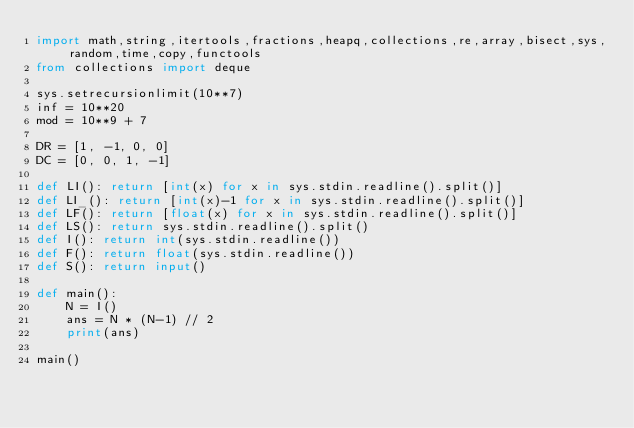<code> <loc_0><loc_0><loc_500><loc_500><_Python_>import math,string,itertools,fractions,heapq,collections,re,array,bisect,sys,random,time,copy,functools
from collections import deque

sys.setrecursionlimit(10**7)
inf = 10**20
mod = 10**9 + 7

DR = [1, -1, 0, 0]
DC = [0, 0, 1, -1]

def LI(): return [int(x) for x in sys.stdin.readline().split()]
def LI_(): return [int(x)-1 for x in sys.stdin.readline().split()]
def LF(): return [float(x) for x in sys.stdin.readline().split()]
def LS(): return sys.stdin.readline().split()
def I(): return int(sys.stdin.readline())
def F(): return float(sys.stdin.readline())
def S(): return input()
     
def main():
    N = I()
    ans = N * (N-1) // 2
    print(ans)

main()

</code> 